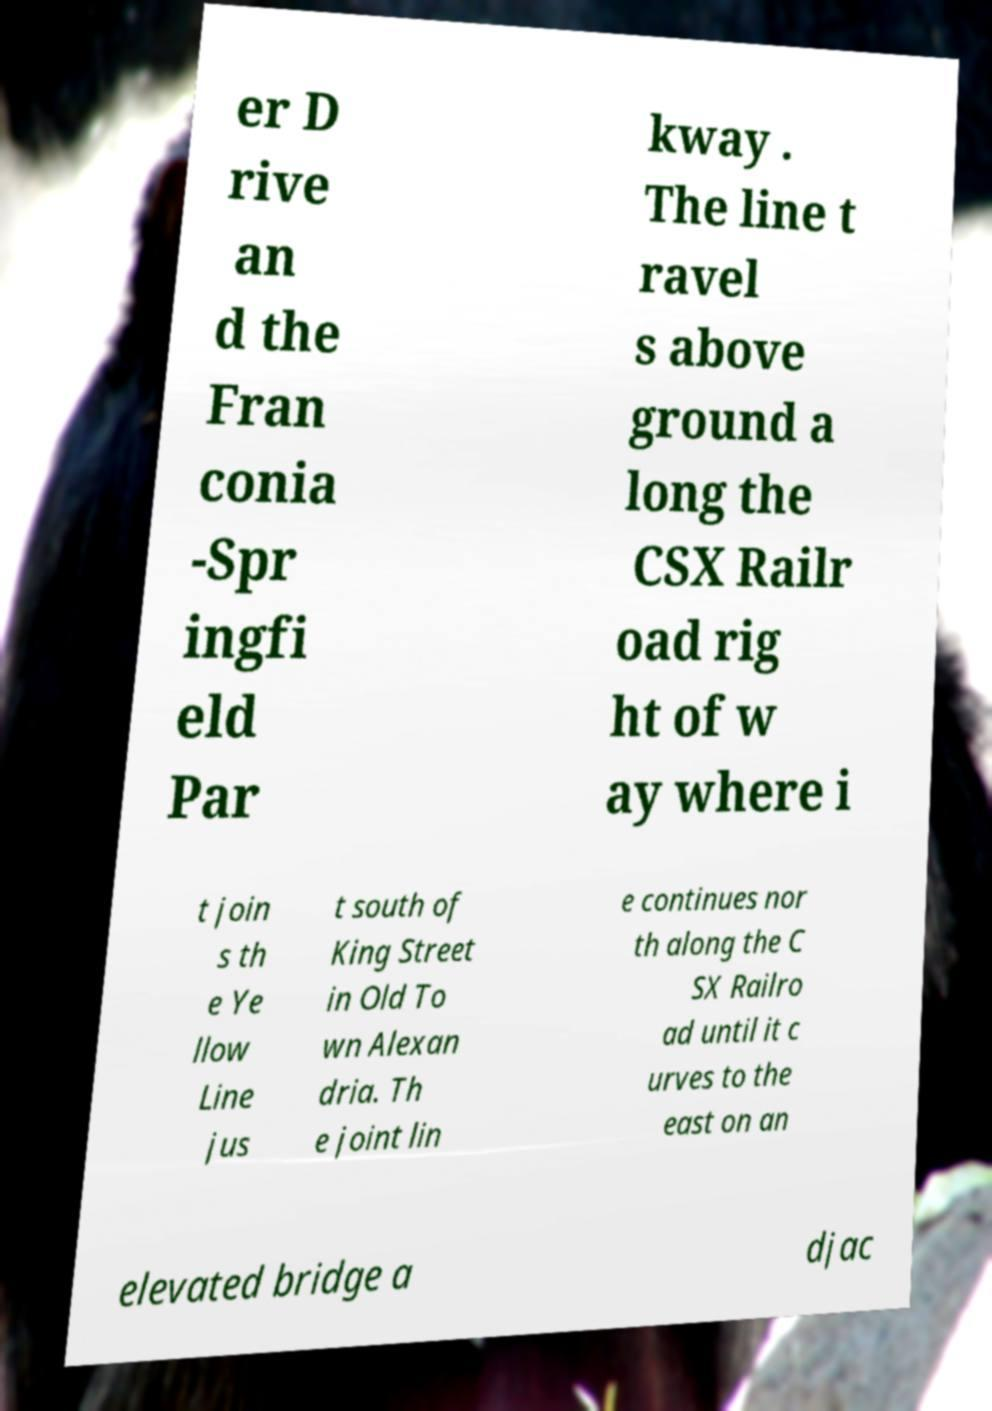Can you accurately transcribe the text from the provided image for me? er D rive an d the Fran conia -Spr ingfi eld Par kway . The line t ravel s above ground a long the CSX Railr oad rig ht of w ay where i t join s th e Ye llow Line jus t south of King Street in Old To wn Alexan dria. Th e joint lin e continues nor th along the C SX Railro ad until it c urves to the east on an elevated bridge a djac 